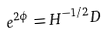<formula> <loc_0><loc_0><loc_500><loc_500>e ^ { 2 \phi } = H ^ { - 1 / 2 } D</formula> 